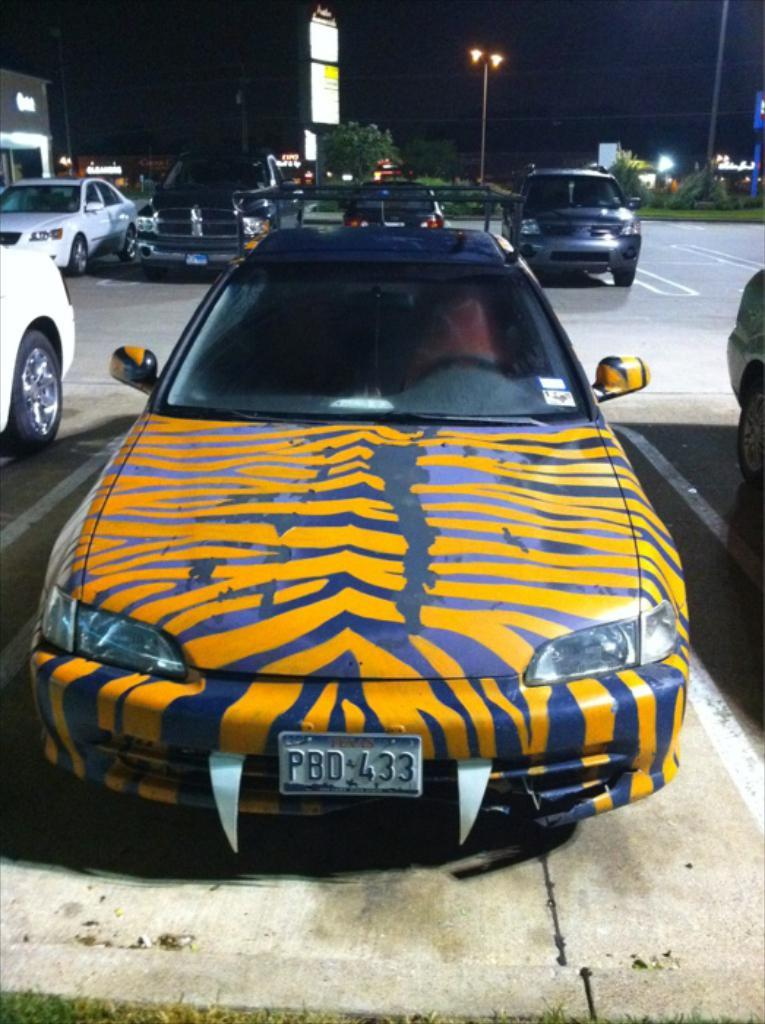Provide a one-sentence caption for the provided image. A car with a Texas license plate has yellow stripes. 